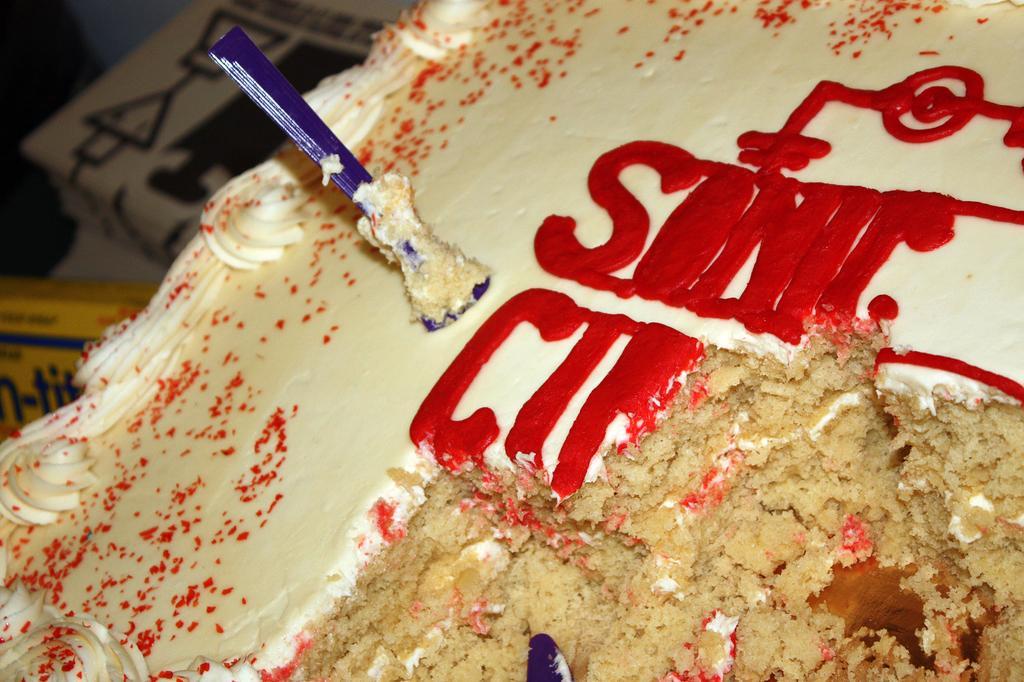How would you summarize this image in a sentence or two? This image consist of food which is in the front and on the left side there are boxes which are yellow and brown in colour. 